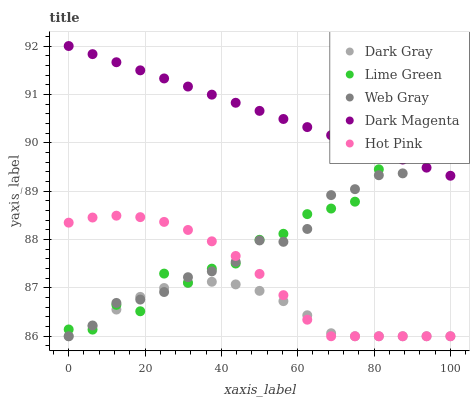Does Dark Gray have the minimum area under the curve?
Answer yes or no. Yes. Does Dark Magenta have the maximum area under the curve?
Answer yes or no. Yes. Does Web Gray have the minimum area under the curve?
Answer yes or no. No. Does Web Gray have the maximum area under the curve?
Answer yes or no. No. Is Dark Magenta the smoothest?
Answer yes or no. Yes. Is Lime Green the roughest?
Answer yes or no. Yes. Is Web Gray the smoothest?
Answer yes or no. No. Is Web Gray the roughest?
Answer yes or no. No. Does Dark Gray have the lowest value?
Answer yes or no. Yes. Does Lime Green have the lowest value?
Answer yes or no. No. Does Dark Magenta have the highest value?
Answer yes or no. Yes. Does Web Gray have the highest value?
Answer yes or no. No. Is Dark Gray less than Dark Magenta?
Answer yes or no. Yes. Is Dark Magenta greater than Hot Pink?
Answer yes or no. Yes. Does Dark Gray intersect Lime Green?
Answer yes or no. Yes. Is Dark Gray less than Lime Green?
Answer yes or no. No. Is Dark Gray greater than Lime Green?
Answer yes or no. No. Does Dark Gray intersect Dark Magenta?
Answer yes or no. No. 